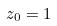Convert formula to latex. <formula><loc_0><loc_0><loc_500><loc_500>z _ { 0 } = 1</formula> 